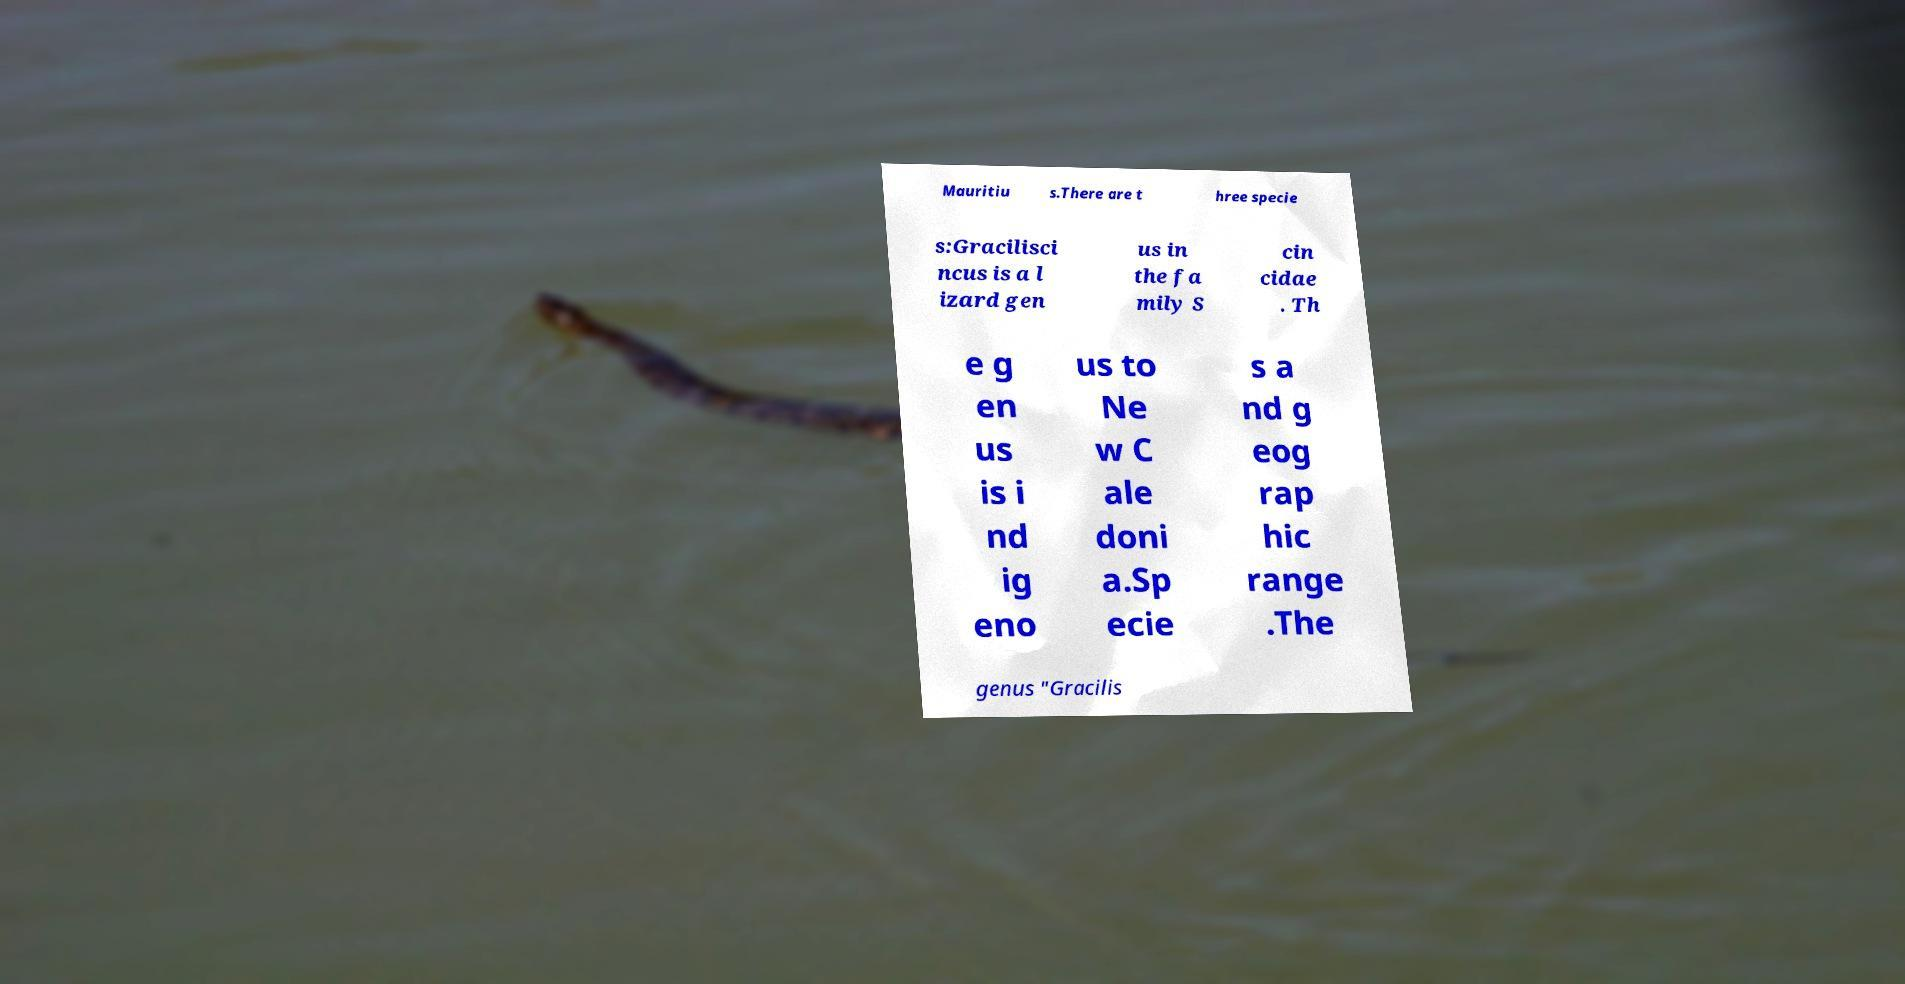Could you extract and type out the text from this image? Mauritiu s.There are t hree specie s:Gracilisci ncus is a l izard gen us in the fa mily S cin cidae . Th e g en us is i nd ig eno us to Ne w C ale doni a.Sp ecie s a nd g eog rap hic range .The genus "Gracilis 